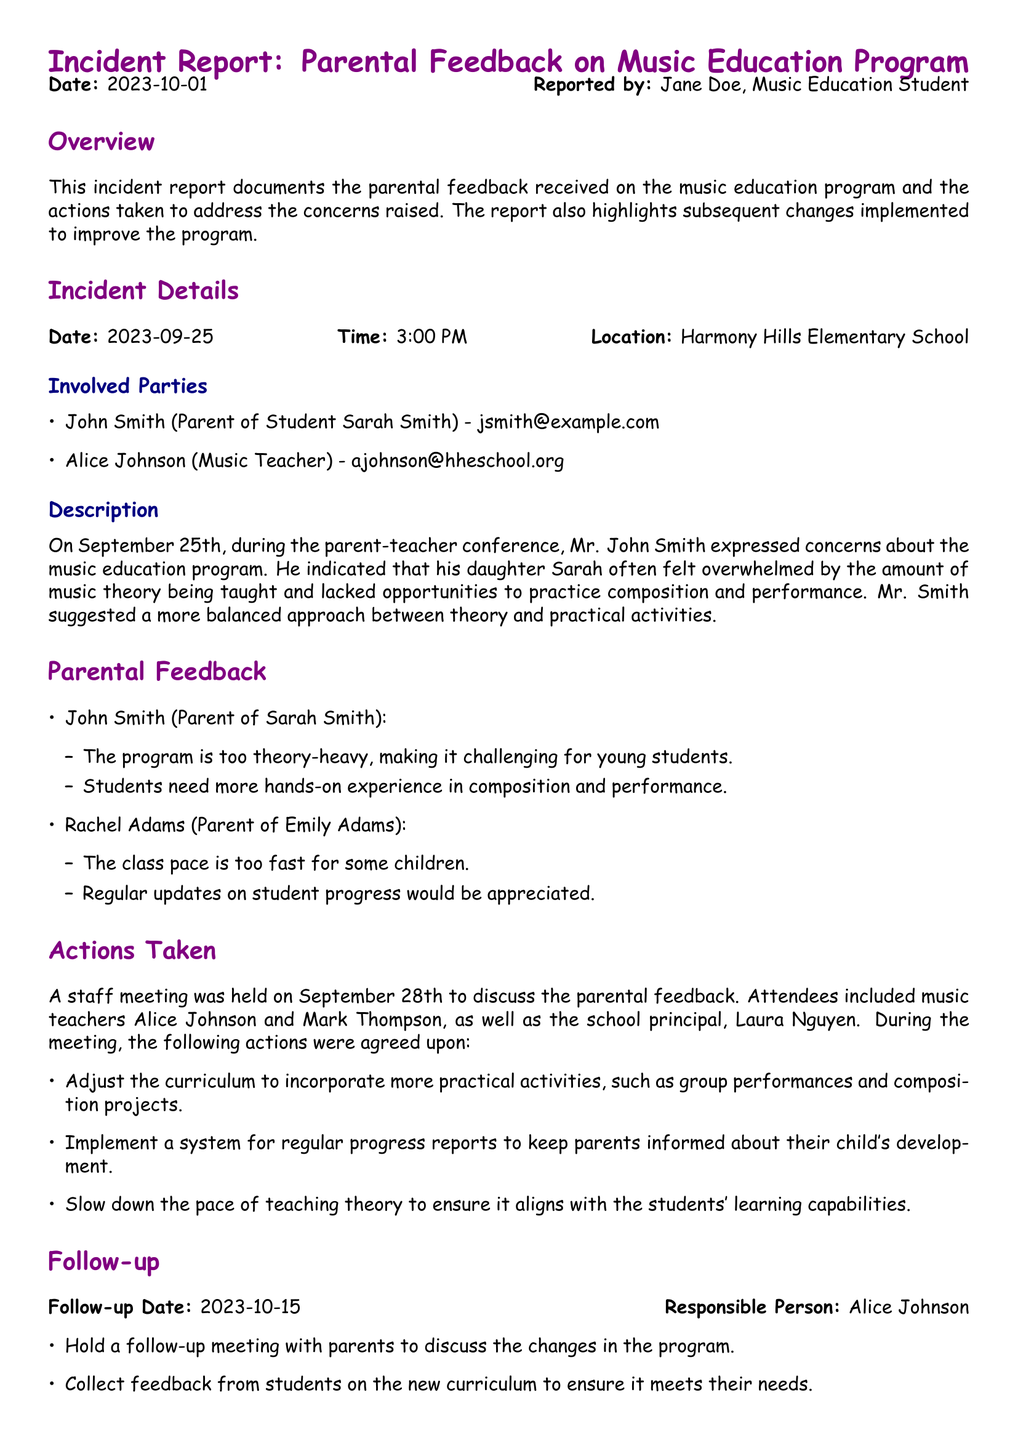What date was the incident reported? The report states that the incident was documented on October 1, 2023.
Answer: October 1, 2023 Who expressed concerns about the music education program? The document indicates that John Smith raised concerns during the parent-teacher conference.
Answer: John Smith What was the primary concern raised by John Smith? John Smith mentioned that the program is too theory-heavy for young students, making it challenging.
Answer: Theory-heavy How many parents provided feedback in the report? The document lists feedback from two parents: John Smith and Rachel Adams.
Answer: Two What is the date of the follow-up meeting? The follow-up date according to the report is October 15, 2023.
Answer: October 15, 2023 What did the meeting on September 28th address? The meeting was held to discuss the parental feedback received regarding the music program.
Answer: Parental feedback What will Alice Johnson do on the follow-up date? Alice Johnson is responsible for holding a follow-up meeting with parents on the follow-up date.
Answer: Follow-up meeting Which aspect of the program will be adjusted according to the actions taken? The curriculum will be adjusted to include more practical activities, such as group performances.
Answer: Practical activities What kind of updates did Rachel Adams request? Rachel Adams requested regular updates on student progress.
Answer: Regular updates 